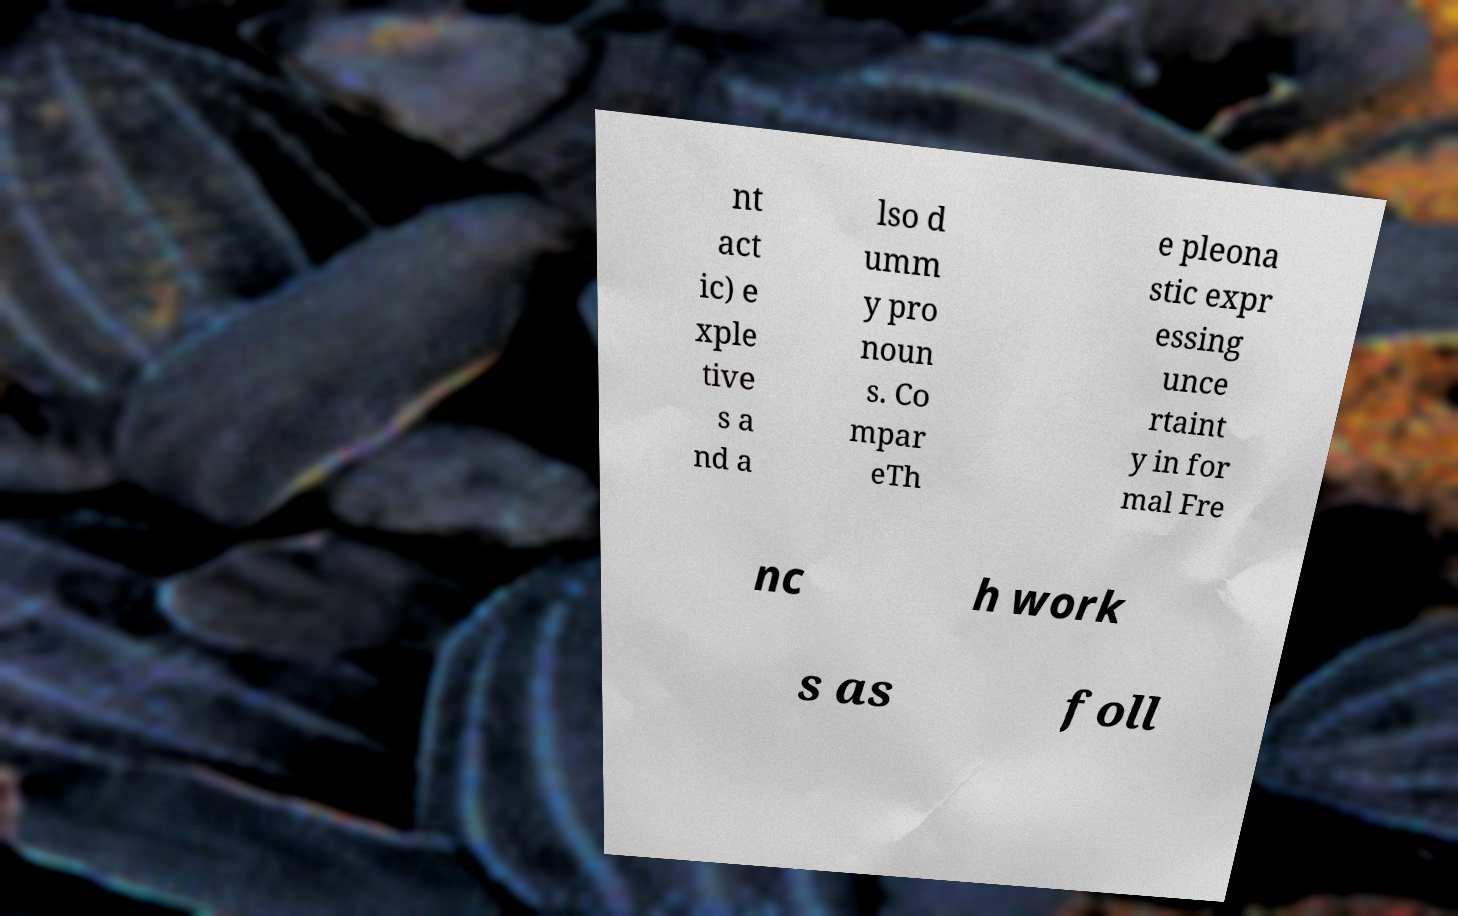Can you read and provide the text displayed in the image?This photo seems to have some interesting text. Can you extract and type it out for me? nt act ic) e xple tive s a nd a lso d umm y pro noun s. Co mpar eTh e pleona stic expr essing unce rtaint y in for mal Fre nc h work s as foll 